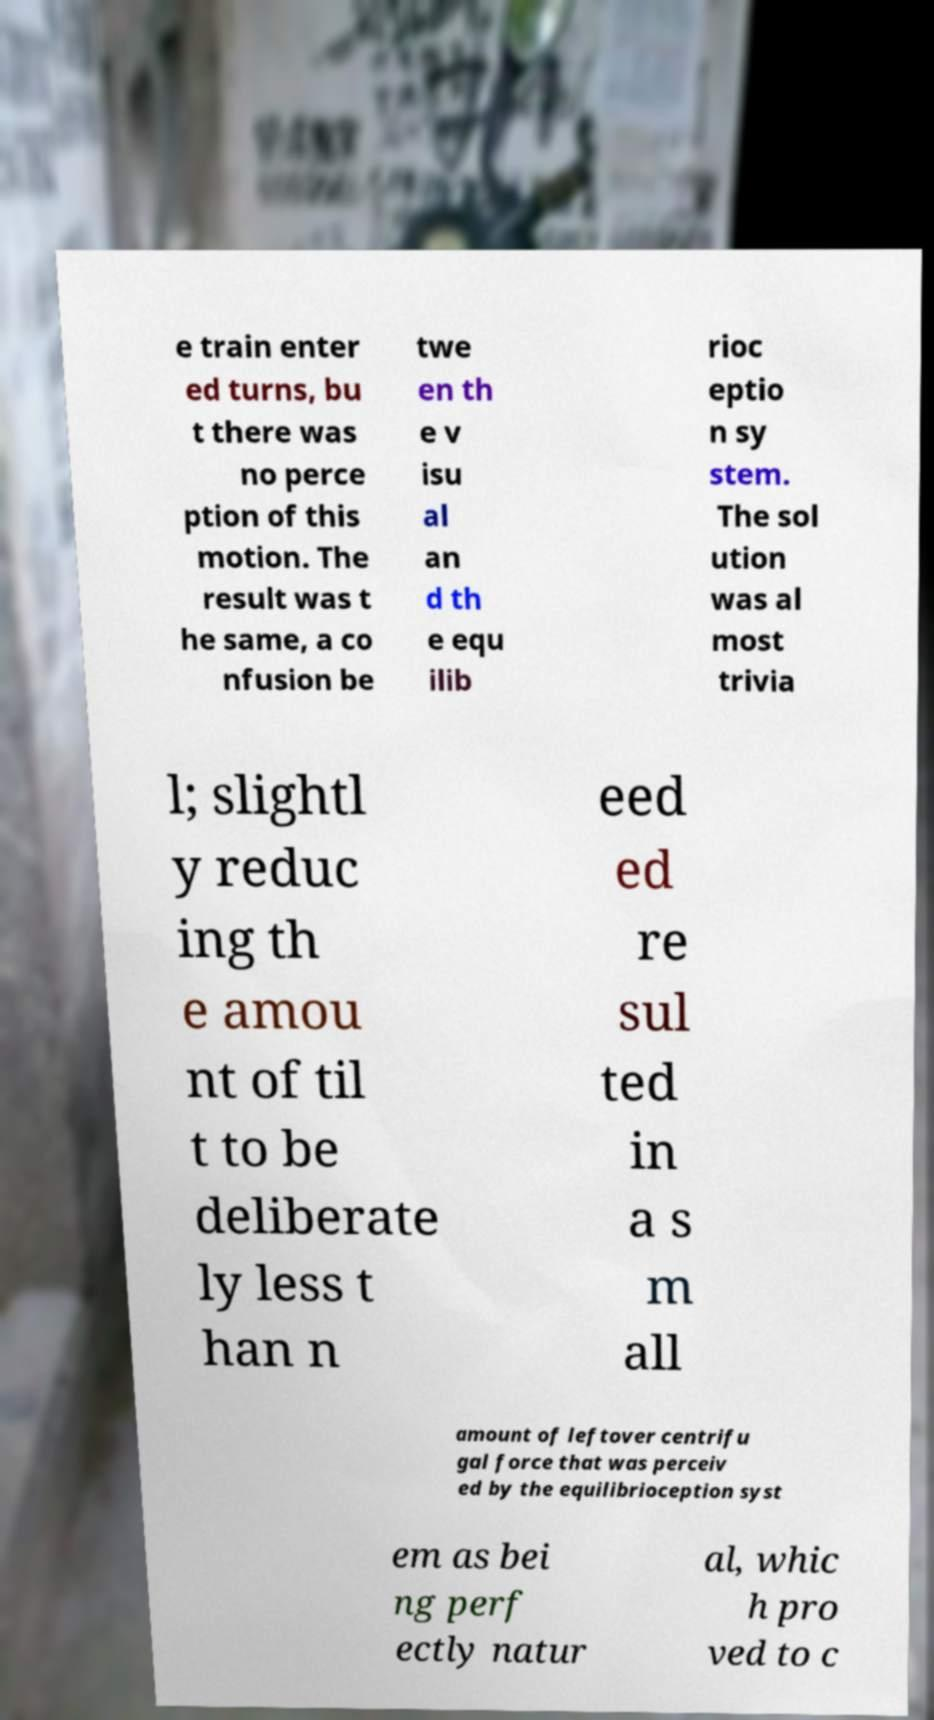What messages or text are displayed in this image? I need them in a readable, typed format. e train enter ed turns, bu t there was no perce ption of this motion. The result was t he same, a co nfusion be twe en th e v isu al an d th e equ ilib rioc eptio n sy stem. The sol ution was al most trivia l; slightl y reduc ing th e amou nt of til t to be deliberate ly less t han n eed ed re sul ted in a s m all amount of leftover centrifu gal force that was perceiv ed by the equilibrioception syst em as bei ng perf ectly natur al, whic h pro ved to c 